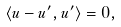Convert formula to latex. <formula><loc_0><loc_0><loc_500><loc_500>\langle u - u ^ { \prime } , u ^ { \prime } \rangle = 0 ,</formula> 